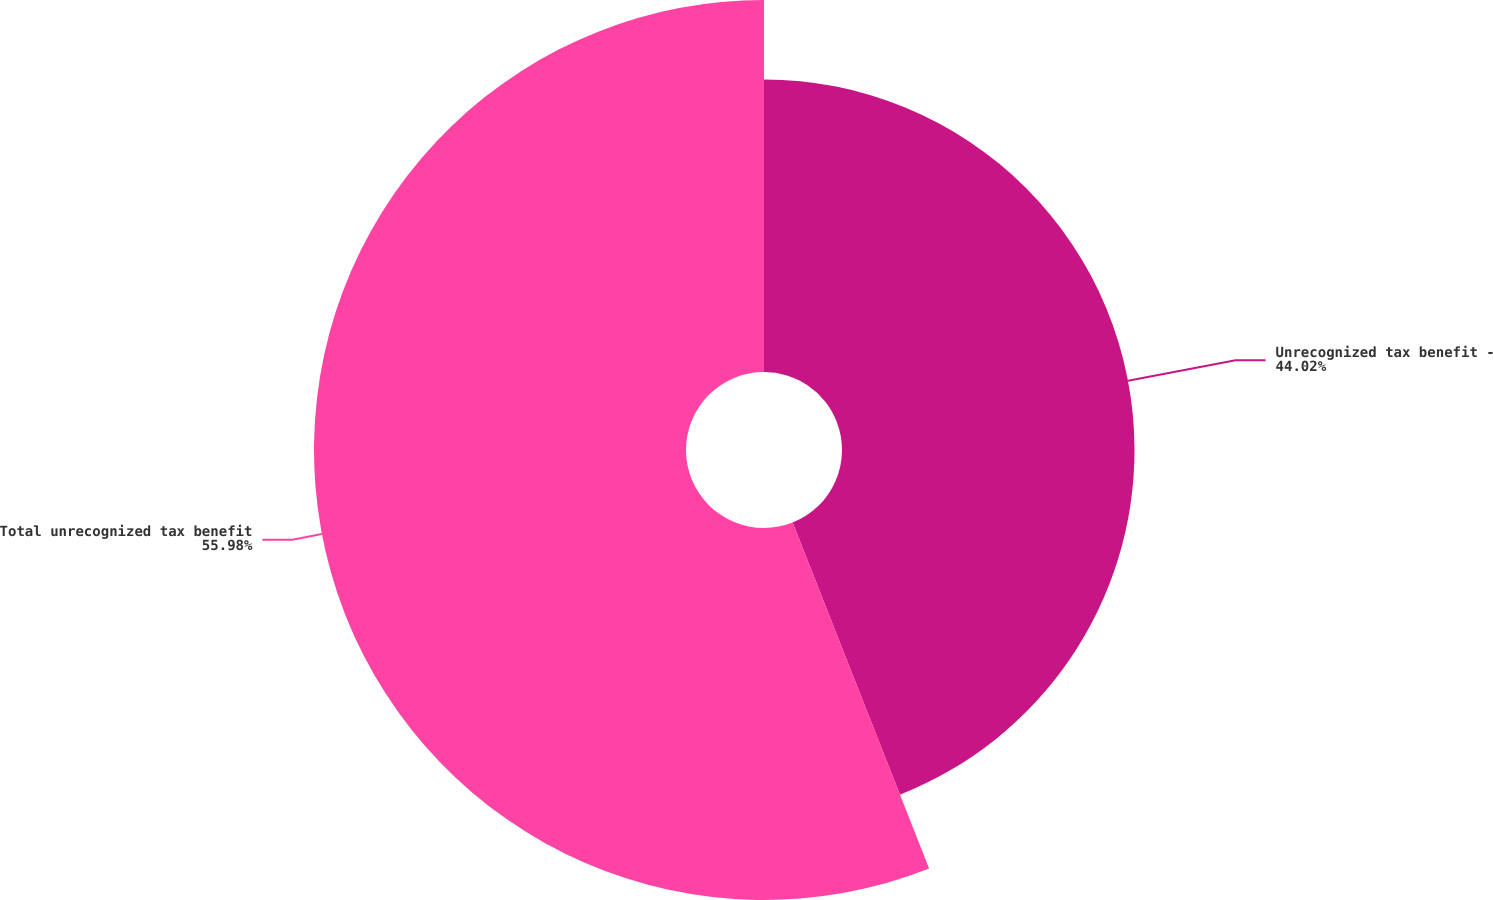Convert chart. <chart><loc_0><loc_0><loc_500><loc_500><pie_chart><fcel>Unrecognized tax benefit -<fcel>Total unrecognized tax benefit<nl><fcel>44.02%<fcel>55.98%<nl></chart> 